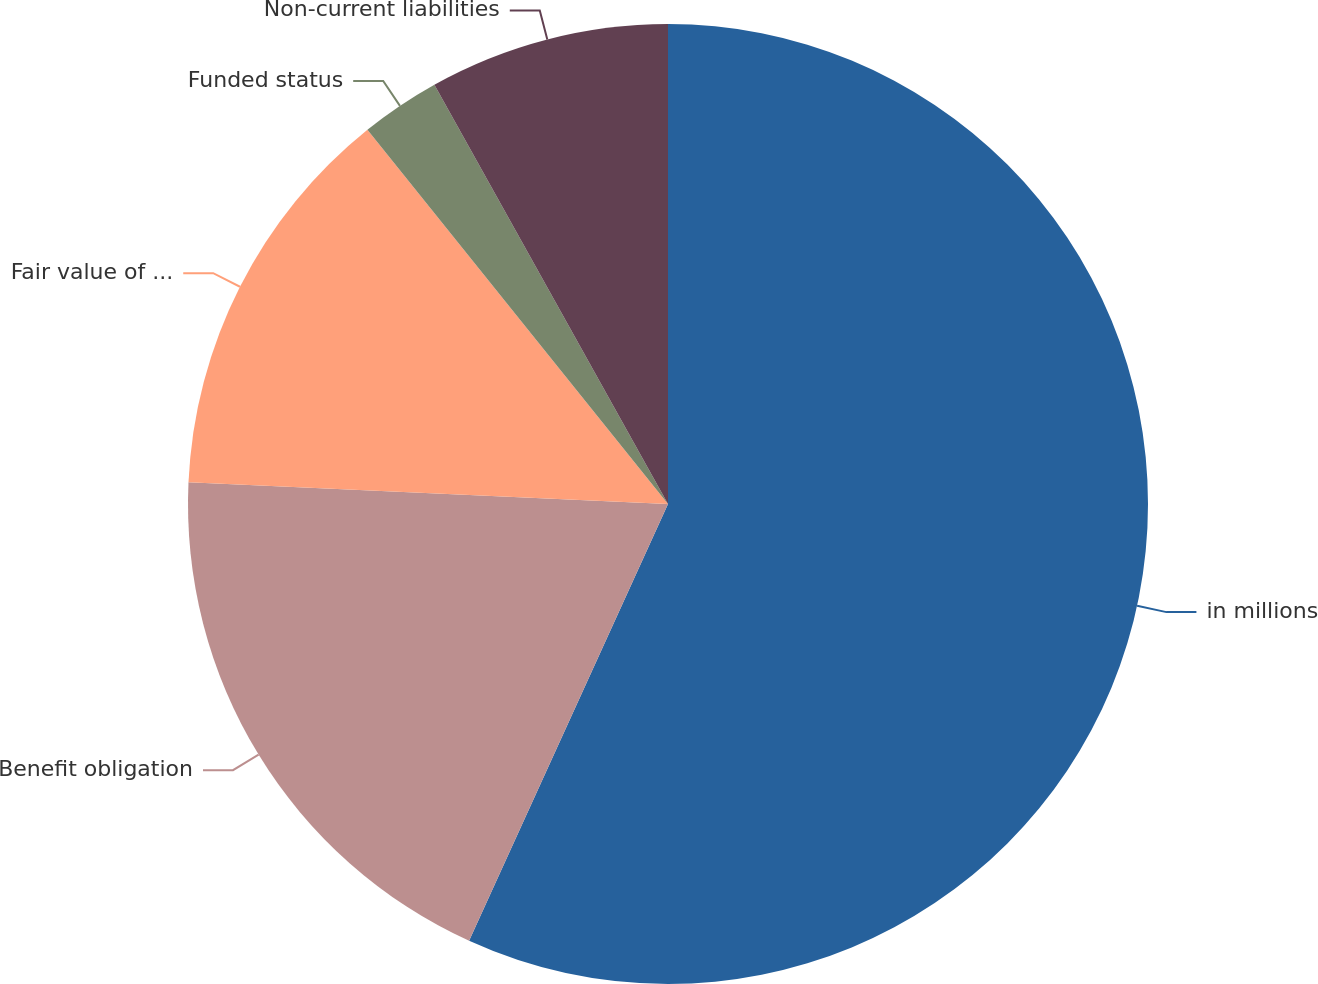Convert chart to OTSL. <chart><loc_0><loc_0><loc_500><loc_500><pie_chart><fcel>in millions<fcel>Benefit obligation<fcel>Fair value of plan assets<fcel>Funded status<fcel>Non-current liabilities<nl><fcel>56.8%<fcel>18.92%<fcel>13.51%<fcel>2.68%<fcel>8.09%<nl></chart> 